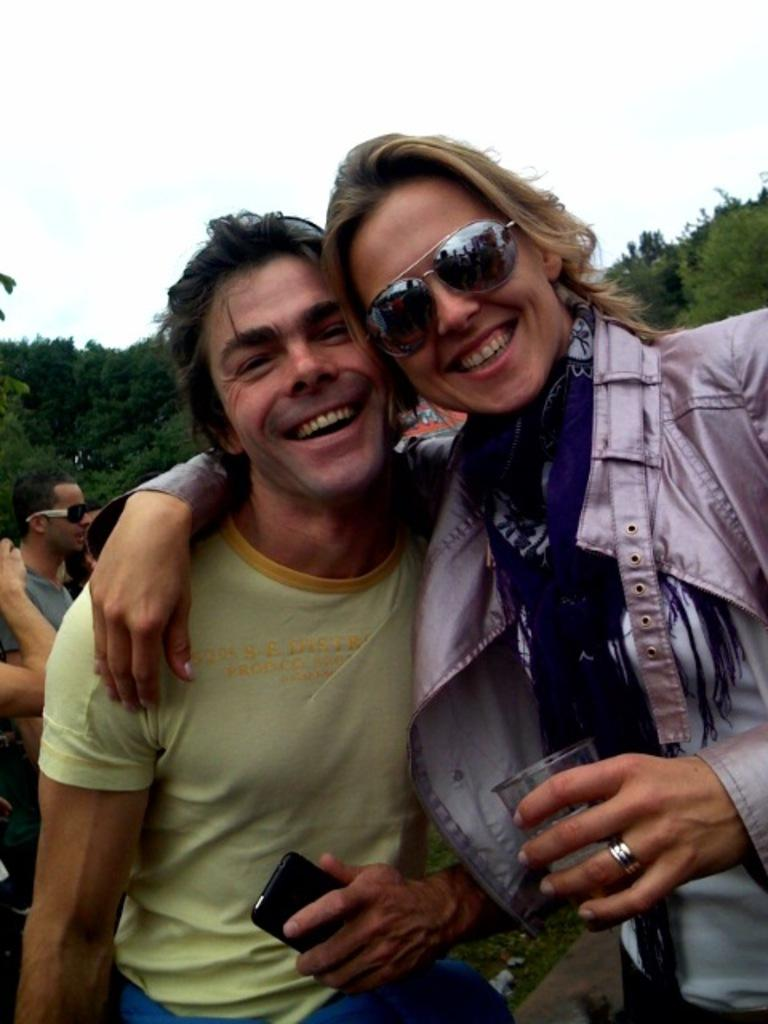What is happening on the road in the image? There is a group of people on the road in the image. What electronic device can be seen in the image? There is a mobile in the image. What type of object made of glass is present in the image? There is a glass object in the image. What protective eyewear is visible in the image? There are goggles in the image. What natural elements can be seen in the background of the image? There are trees and the sky visible in the background of the image. Can you determine the time of day based on the image? The image appears to be taken during the day. Where is the doll located in the image? There is no doll present in the image. What type of chain is being used to secure the goggles in the image? There is no chain visible in the image; the goggles are not secured with a chain. 